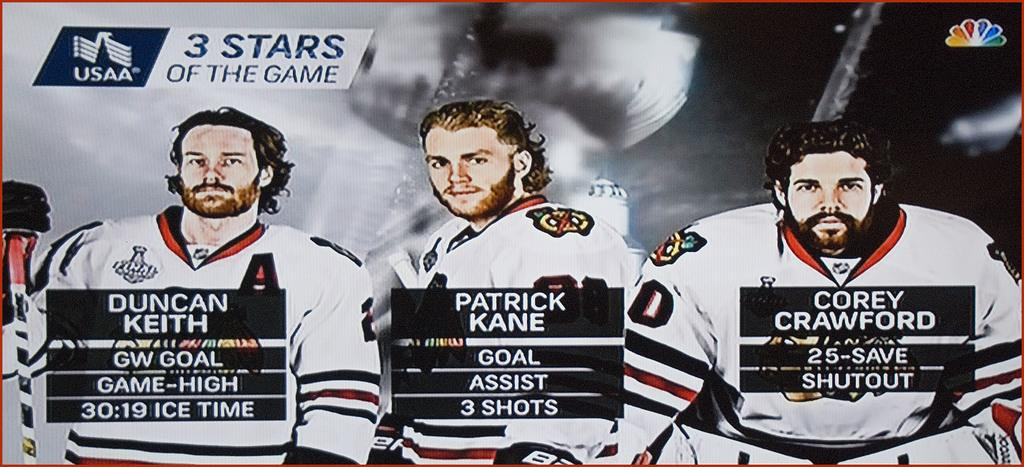<image>
Create a compact narrative representing the image presented. A screen shot of Ice Hockey player stats showing Duncan Keith, Patrick Kane and Corey Crawfords stats. 